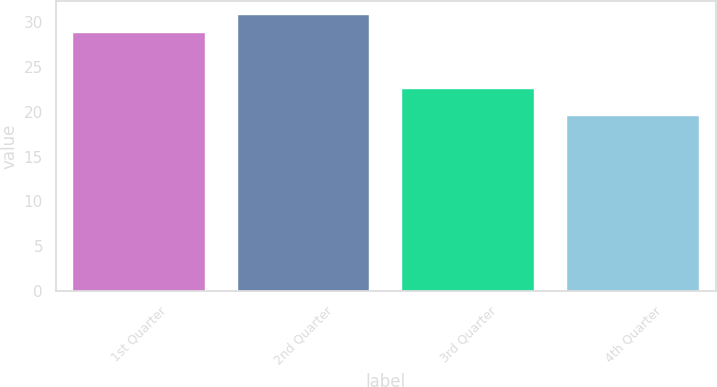<chart> <loc_0><loc_0><loc_500><loc_500><bar_chart><fcel>1st Quarter<fcel>2nd Quarter<fcel>3rd Quarter<fcel>4th Quarter<nl><fcel>28.78<fcel>30.8<fcel>22.55<fcel>19.52<nl></chart> 